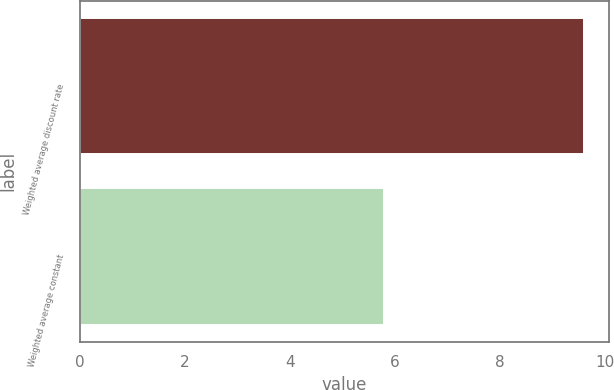<chart> <loc_0><loc_0><loc_500><loc_500><bar_chart><fcel>Weighted average discount rate<fcel>Weighted average constant<nl><fcel>9.6<fcel>5.8<nl></chart> 